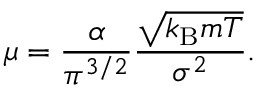<formula> <loc_0><loc_0><loc_500><loc_500>\mu = { \frac { \alpha } { \pi ^ { 3 / 2 } } } { \frac { \sqrt { k _ { B } m T } } { \sigma ^ { 2 } } } .</formula> 